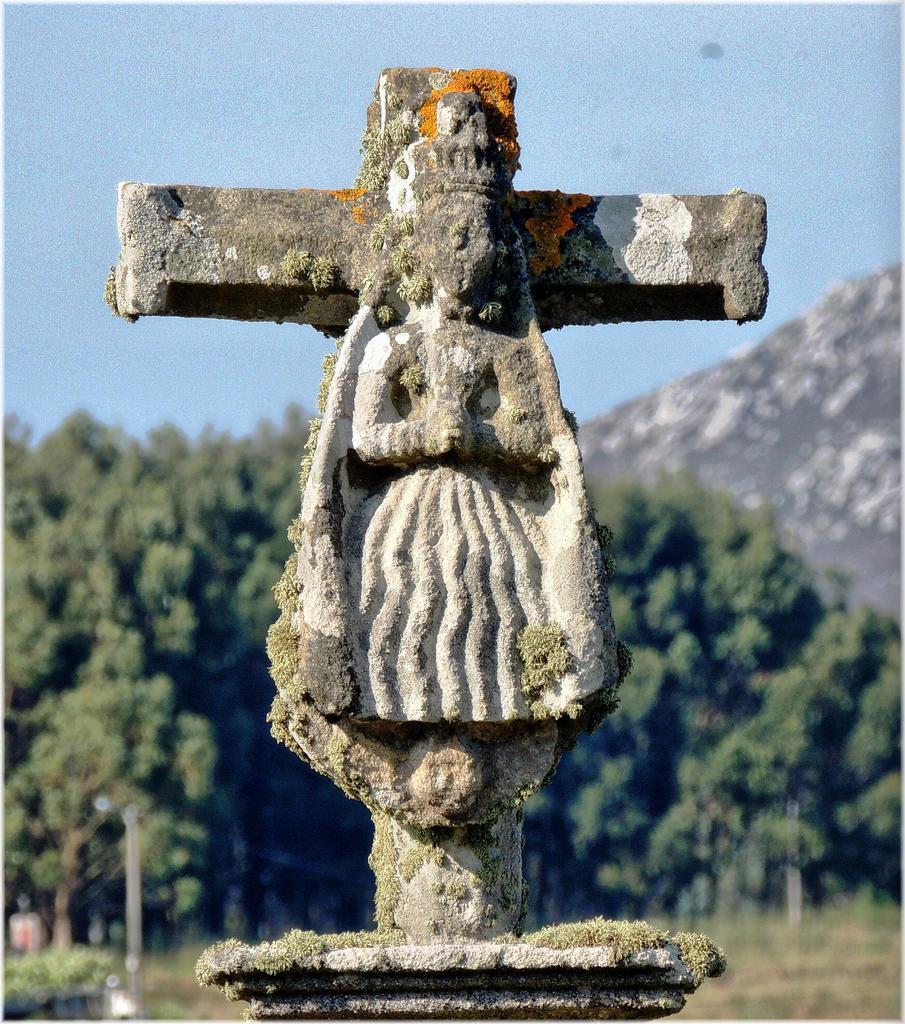Please provide a concise description of this image. In this picture we can see a stone carving. In the background we can see sky, trees and a hill. 